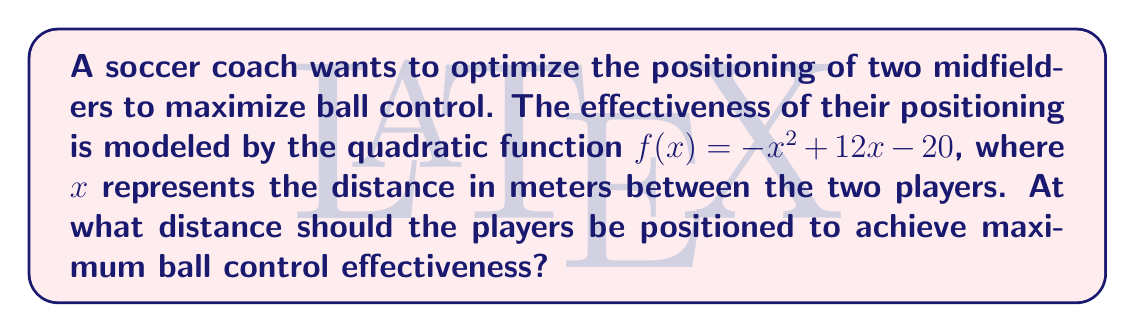Teach me how to tackle this problem. To find the optimal distance between the two players, we need to find the maximum value of the quadratic function $f(x) = -x^2 + 12x - 20$.

Step 1: Identify the quadratic equation
$f(x) = -x^2 + 12x - 20$

Step 2: Find the axis of symmetry
For a quadratic function in the form $f(x) = ax^2 + bx + c$, the axis of symmetry is given by $x = -\frac{b}{2a}$.

In this case, $a = -1$ and $b = 12$:
$x = -\frac{12}{2(-1)} = -\frac{12}{-2} = 6$

Step 3: Verify that this is a maximum
Since the coefficient of $x^2$ is negative ($a = -1$), the parabola opens downward, confirming that $x = 6$ gives the maximum value.

Step 4: Interpret the result
The optimal distance between the two midfielders to maximize ball control effectiveness is 6 meters.
Answer: 6 meters 